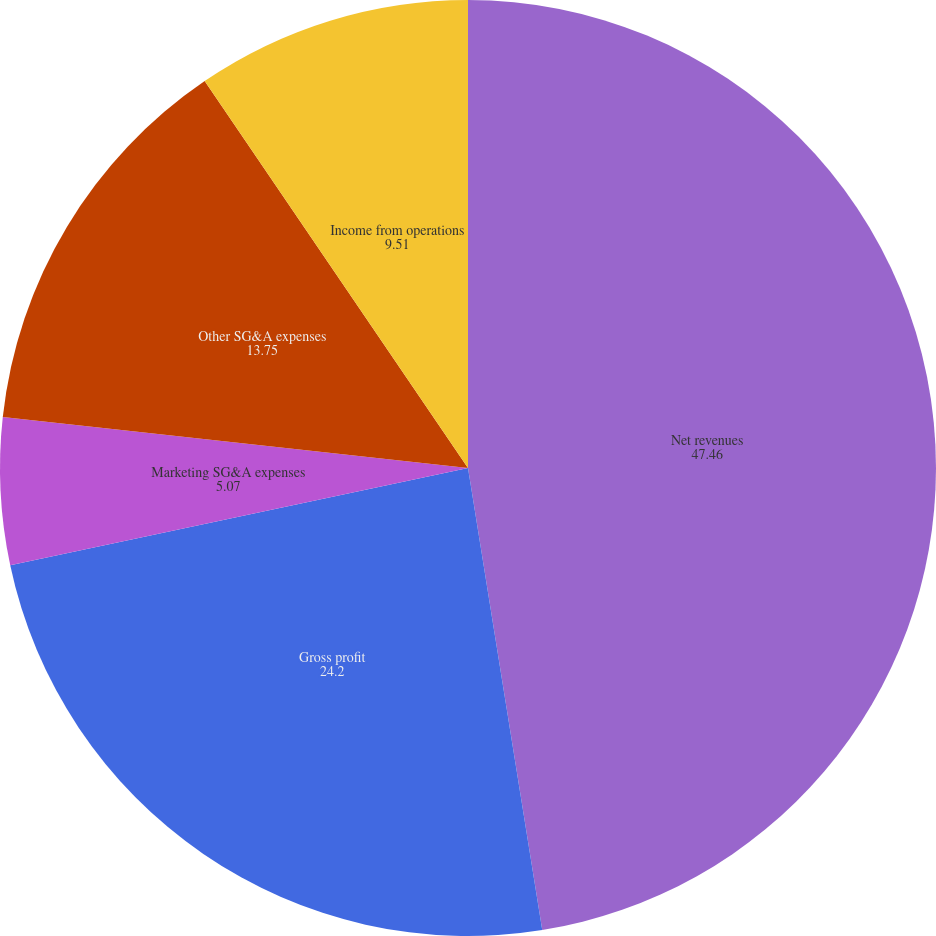Convert chart to OTSL. <chart><loc_0><loc_0><loc_500><loc_500><pie_chart><fcel>Net revenues<fcel>Gross profit<fcel>Marketing SG&A expenses<fcel>Other SG&A expenses<fcel>Income from operations<nl><fcel>47.46%<fcel>24.2%<fcel>5.07%<fcel>13.75%<fcel>9.51%<nl></chart> 